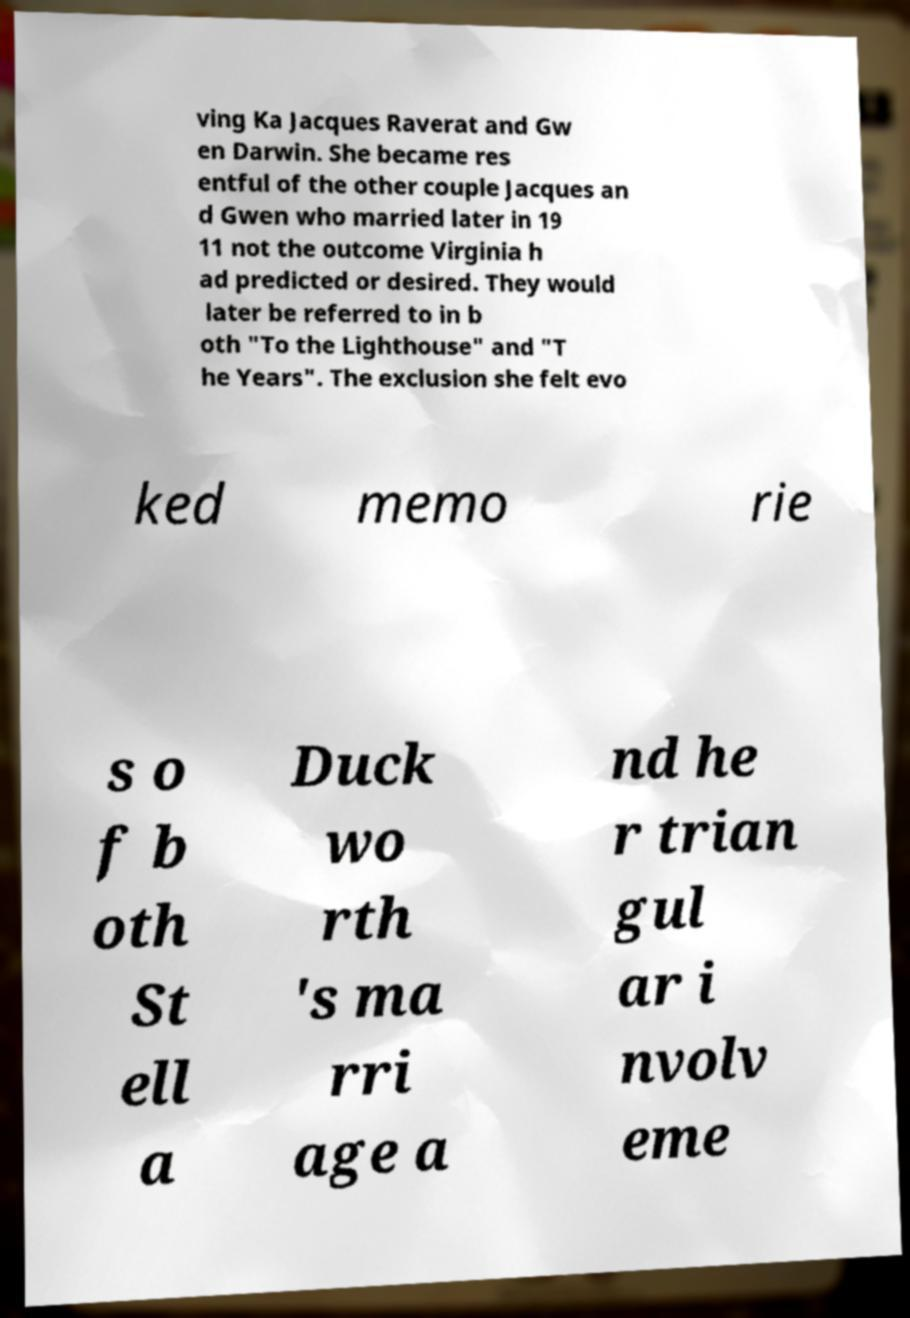Please identify and transcribe the text found in this image. ving Ka Jacques Raverat and Gw en Darwin. She became res entful of the other couple Jacques an d Gwen who married later in 19 11 not the outcome Virginia h ad predicted or desired. They would later be referred to in b oth "To the Lighthouse" and "T he Years". The exclusion she felt evo ked memo rie s o f b oth St ell a Duck wo rth 's ma rri age a nd he r trian gul ar i nvolv eme 